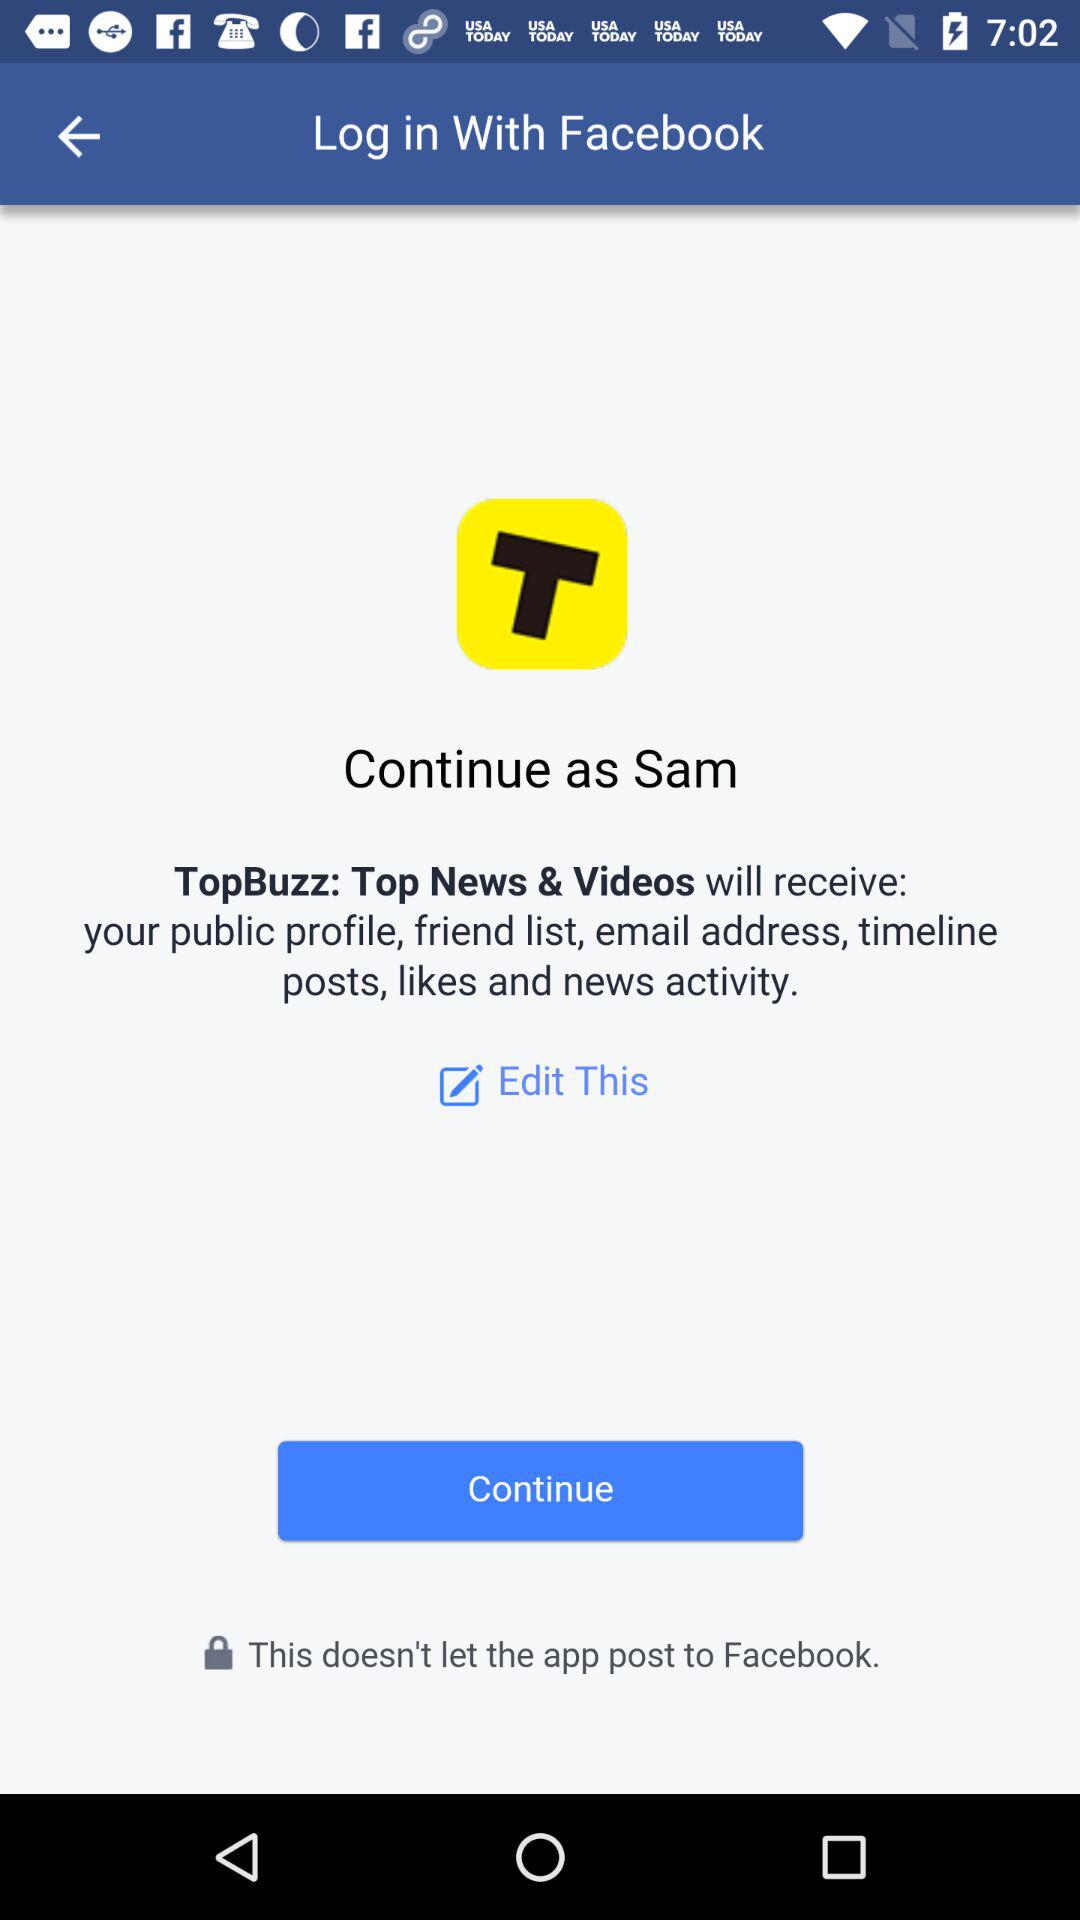Through what application is the person logging in? The person is logging in through "Facebook". 